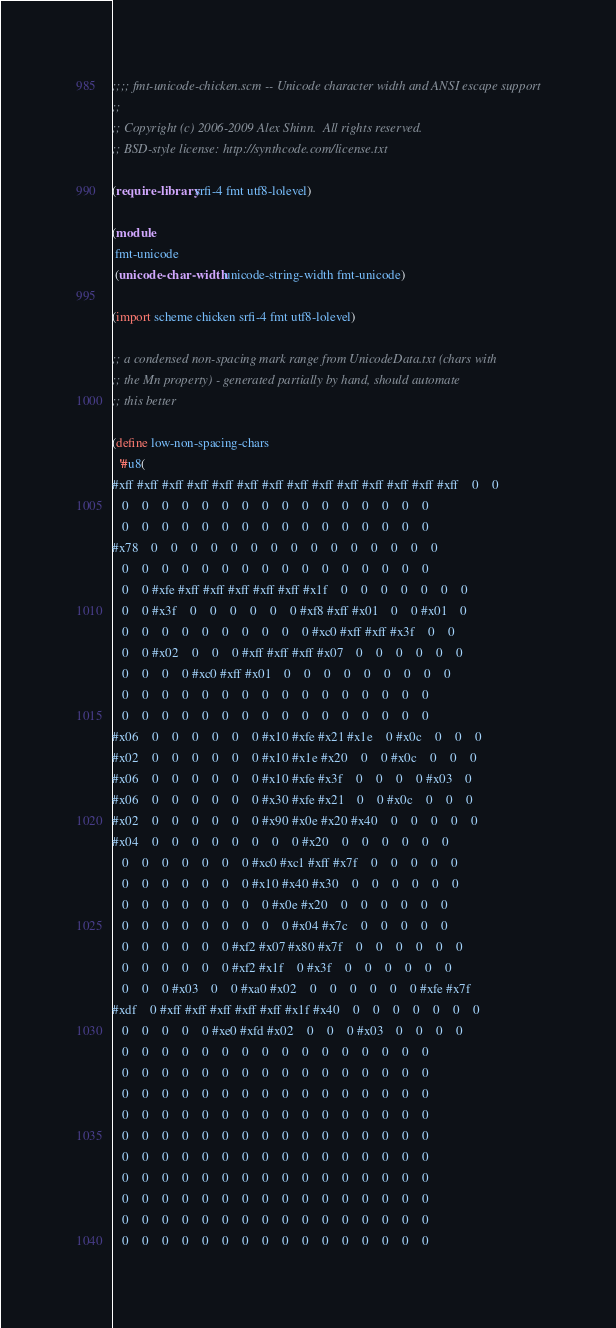Convert code to text. <code><loc_0><loc_0><loc_500><loc_500><_Scheme_>;;;; fmt-unicode-chicken.scm -- Unicode character width and ANSI escape support
;;
;; Copyright (c) 2006-2009 Alex Shinn.  All rights reserved.
;; BSD-style license: http://synthcode.com/license.txt

(require-library srfi-4 fmt utf8-lolevel)

(module
 fmt-unicode
 (unicode-char-width unicode-string-width fmt-unicode)

(import scheme chicken srfi-4 fmt utf8-lolevel)

;; a condensed non-spacing mark range from UnicodeData.txt (chars with
;; the Mn property) - generated partially by hand, should automate
;; this better

(define low-non-spacing-chars
  '#u8(
#xff #xff #xff #xff #xff #xff #xff #xff #xff #xff #xff #xff #xff #xff    0    0
   0    0    0    0    0    0    0    0    0    0    0    0    0    0    0    0
   0    0    0    0    0    0    0    0    0    0    0    0    0    0    0    0
#x78    0    0    0    0    0    0    0    0    0    0    0    0    0    0    0
   0    0    0    0    0    0    0    0    0    0    0    0    0    0    0    0
   0    0 #xfe #xff #xff #xff #xff #xff #x1f    0    0    0    0    0    0    0
   0    0 #x3f    0    0    0    0    0    0 #xf8 #xff #x01    0    0 #x01    0
   0    0    0    0    0    0    0    0    0    0 #xc0 #xff #xff #x3f    0    0
   0    0 #x02    0    0    0 #xff #xff #xff #x07    0    0    0    0    0    0
   0    0    0    0 #xc0 #xff #x01    0    0    0    0    0    0    0    0    0
   0    0    0    0    0    0    0    0    0    0    0    0    0    0    0    0
   0    0    0    0    0    0    0    0    0    0    0    0    0    0    0    0
#x06    0    0    0    0    0    0 #x10 #xfe #x21 #x1e    0 #x0c    0    0    0
#x02    0    0    0    0    0    0 #x10 #x1e #x20    0    0 #x0c    0    0    0
#x06    0    0    0    0    0    0 #x10 #xfe #x3f    0    0    0    0 #x03    0
#x06    0    0    0    0    0    0 #x30 #xfe #x21    0    0 #x0c    0    0    0
#x02    0    0    0    0    0    0 #x90 #x0e #x20 #x40    0    0    0    0    0
#x04    0    0    0    0    0    0    0    0 #x20    0    0    0    0    0    0
   0    0    0    0    0    0    0 #xc0 #xc1 #xff #x7f    0    0    0    0    0
   0    0    0    0    0    0    0 #x10 #x40 #x30    0    0    0    0    0    0
   0    0    0    0    0    0    0    0 #x0e #x20    0    0    0    0    0    0
   0    0    0    0    0    0    0    0    0 #x04 #x7c    0    0    0    0    0
   0    0    0    0    0    0 #xf2 #x07 #x80 #x7f    0    0    0    0    0    0
   0    0    0    0    0    0 #xf2 #x1f    0 #x3f    0    0    0    0    0    0
   0    0    0 #x03    0    0 #xa0 #x02    0    0    0    0    0    0 #xfe #x7f
#xdf    0 #xff #xff #xff #xff #xff #x1f #x40    0    0    0    0    0    0    0
   0    0    0    0    0 #xe0 #xfd #x02    0    0    0 #x03    0    0    0    0
   0    0    0    0    0    0    0    0    0    0    0    0    0    0    0    0
   0    0    0    0    0    0    0    0    0    0    0    0    0    0    0    0
   0    0    0    0    0    0    0    0    0    0    0    0    0    0    0    0
   0    0    0    0    0    0    0    0    0    0    0    0    0    0    0    0
   0    0    0    0    0    0    0    0    0    0    0    0    0    0    0    0
   0    0    0    0    0    0    0    0    0    0    0    0    0    0    0    0
   0    0    0    0    0    0    0    0    0    0    0    0    0    0    0    0
   0    0    0    0    0    0    0    0    0    0    0    0    0    0    0    0
   0    0    0    0    0    0    0    0    0    0    0    0    0    0    0    0
   0    0    0    0    0    0    0    0    0    0    0    0    0    0    0    0</code> 